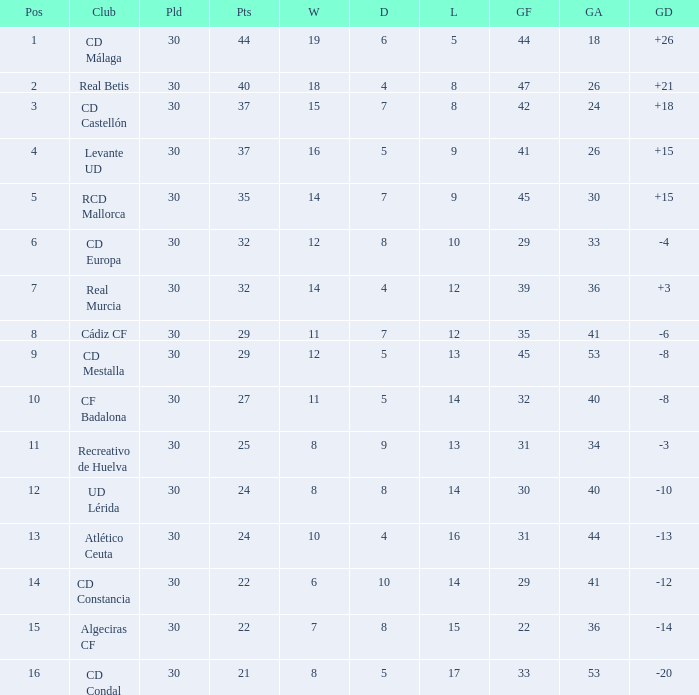What is the goals for when played is larger than 30? None. 